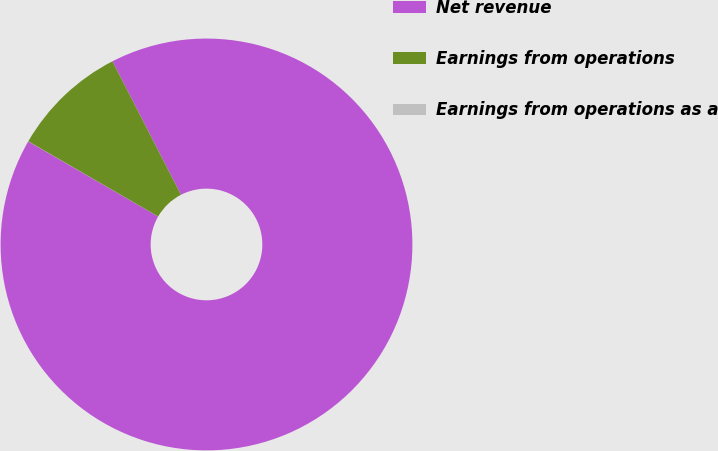Convert chart to OTSL. <chart><loc_0><loc_0><loc_500><loc_500><pie_chart><fcel>Net revenue<fcel>Earnings from operations<fcel>Earnings from operations as a<nl><fcel>90.89%<fcel>9.1%<fcel>0.01%<nl></chart> 